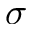<formula> <loc_0><loc_0><loc_500><loc_500>\sigma</formula> 